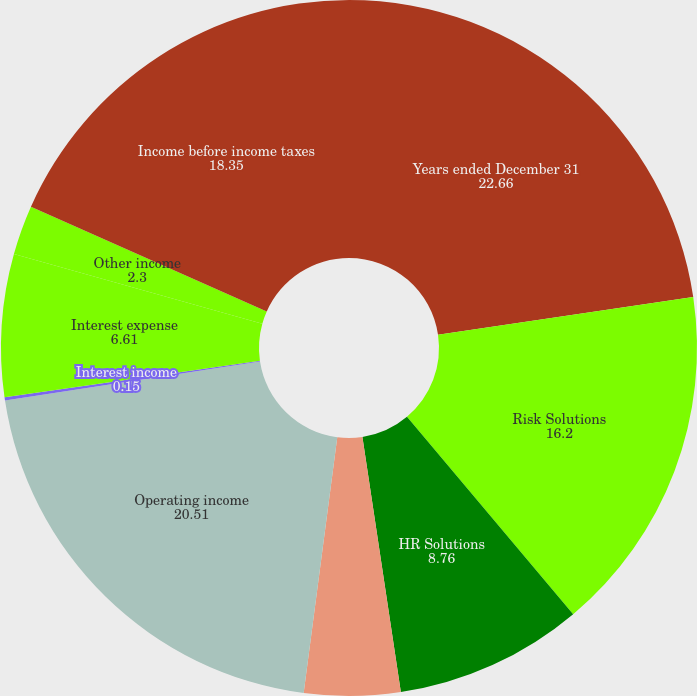Convert chart. <chart><loc_0><loc_0><loc_500><loc_500><pie_chart><fcel>Years ended December 31<fcel>Risk Solutions<fcel>HR Solutions<fcel>Unallocated expense<fcel>Operating income<fcel>Interest income<fcel>Interest expense<fcel>Other income<fcel>Income before income taxes<nl><fcel>22.66%<fcel>16.2%<fcel>8.76%<fcel>4.46%<fcel>20.51%<fcel>0.15%<fcel>6.61%<fcel>2.3%<fcel>18.35%<nl></chart> 